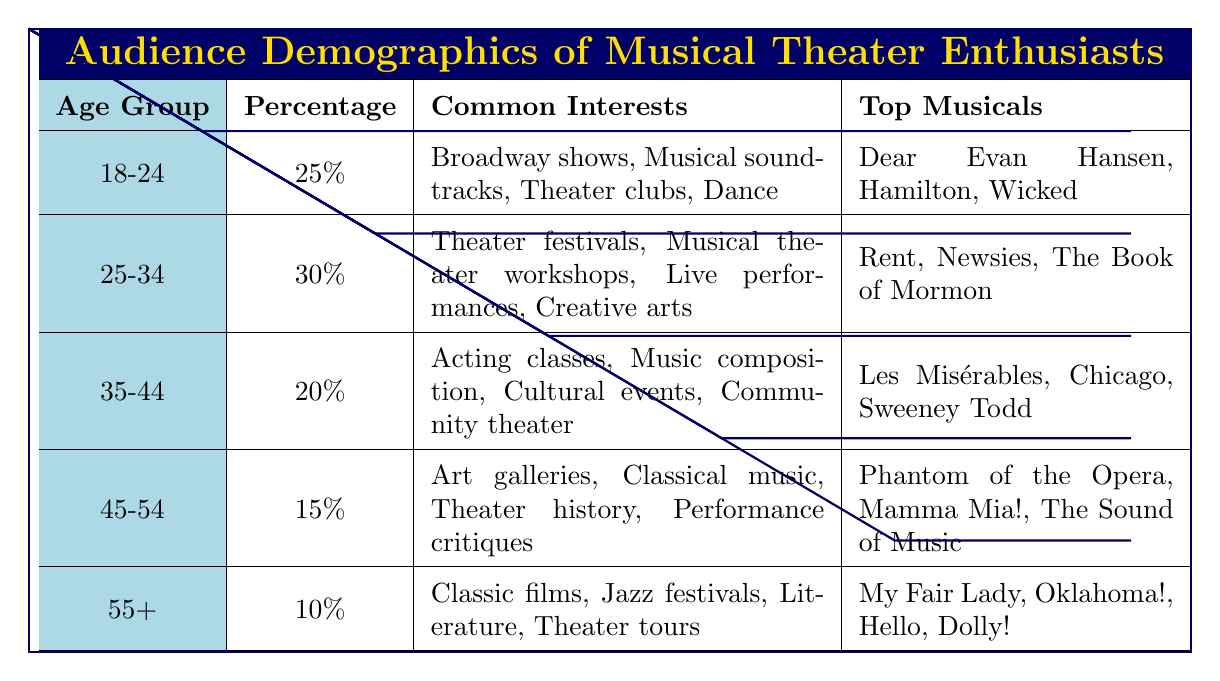What percentage of the audience is aged 25-34? According to the table, the percentage for the age group 25-34 is clearly listed as 30%.
Answer: 30% Which age group has the highest percentage of musical theater enthusiasts? The table shows that the age group 25-34 has the highest percentage at 30%.
Answer: 25-34 What are some common interests of the 18-24 age group? The table lists the common interests for the 18-24 age group as Broadway shows, Musical soundtracks, Theater clubs, and Dance.
Answer: Broadway shows, Musical soundtracks, Theater clubs, Dance Which musicals are favored by the 35-44 age group? The top musicals listed for the 35-44 age group in the table are Les Misérables, Chicago, and Sweeney Todd.
Answer: Les Misérables, Chicago, Sweeney Todd Is the percentage of enthusiasts aged 55 and over greater than those aged 45-54? The percentage for the 55+ age group is 10%, while the 45-54 age group is 15%. Since 10% is less than 15%, the statement is false.
Answer: No What is the total percentage of enthusiasts aged 18-24 and 25-34? From the table, the percentage for 18-24 is 25% and for 25-34 is 30%. Adding these gives 25% + 30% = 55%.
Answer: 55% Which age group is interested in acting classes? The 35-44 age group is listed in the table as having interests that include acting classes.
Answer: 35-44 Among the age groups, what is the percentage difference between the 45-54 and 55+ groups? The percentage for the 45-54 group is 15%, and for the 55+ group it is 10%. The difference is calculated as 15% - 10% = 5%.
Answer: 5% Do enthusiasts aged 25-34 have a higher interest in live performances than those aged 35-44? The 25-34 group lists live performances as a common interest, while the 35-44 group has community theater, which does not specify live performances. Therefore, we can assume the 25-34 group has a higher interest.
Answer: Yes What is the average percentage of all age groups combined? To find the average, sum all percentages: 25% + 30% + 20% + 15% + 10% = 100%. Then divide by the number of groups (5) to get 100% / 5 = 20%.
Answer: 20% 